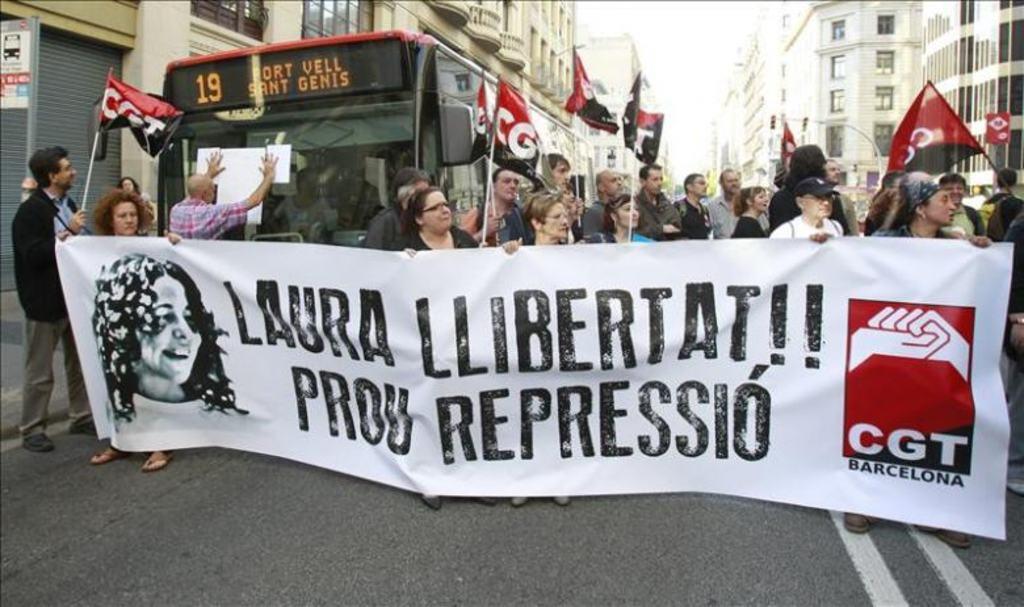Could you give a brief overview of what you see in this image? In this image, we can see people and some are holding a banner and there is some text, a logo and an image of a lady are on the banner. In the background, there are some other people holding flags and we can see buildings, boards and trees. At the bottom, there is a road. 